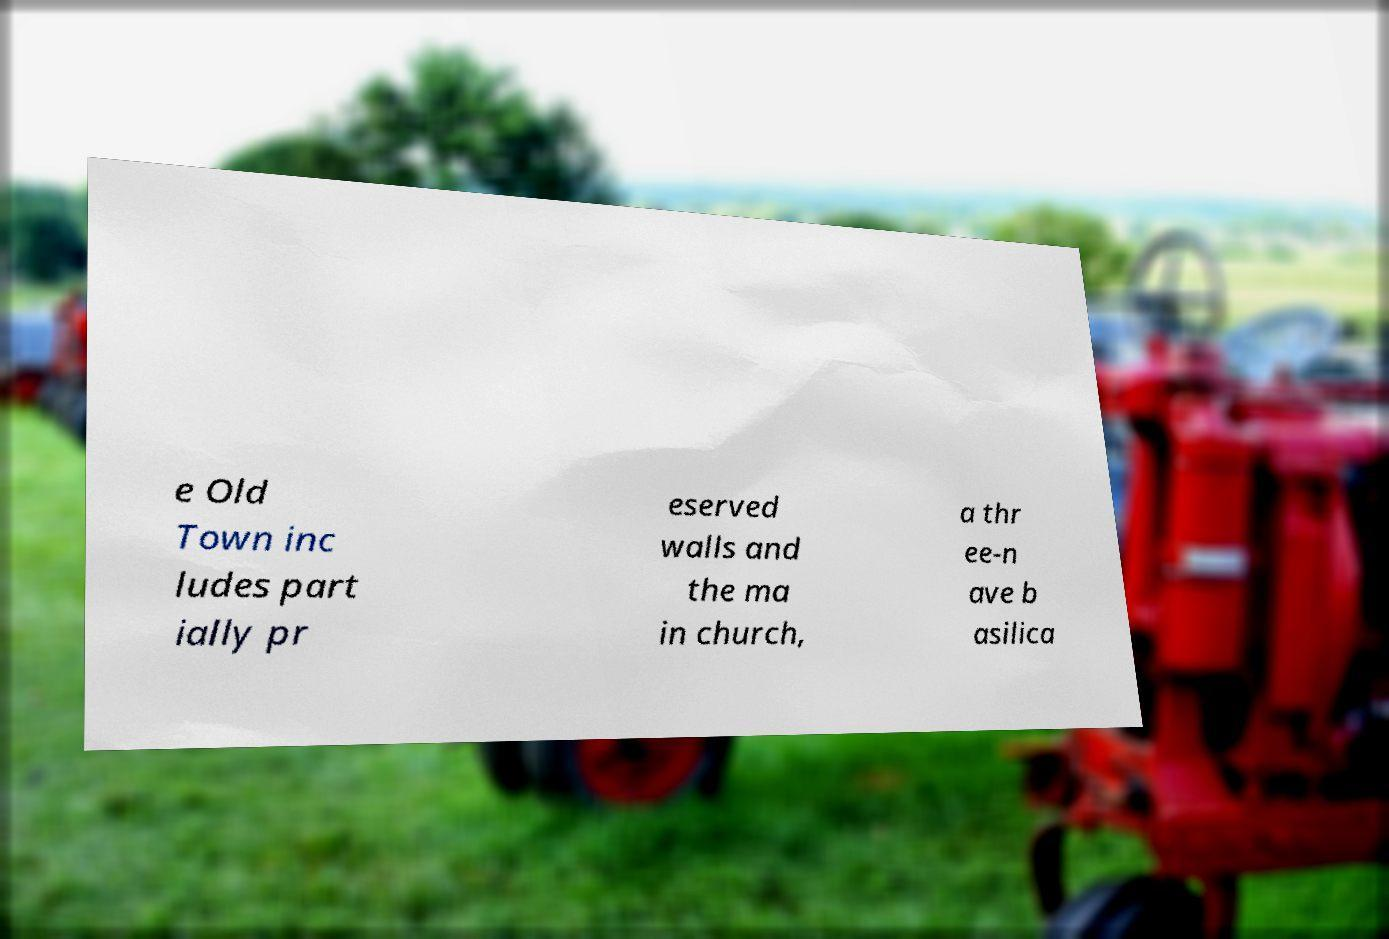I need the written content from this picture converted into text. Can you do that? e Old Town inc ludes part ially pr eserved walls and the ma in church, a thr ee-n ave b asilica 